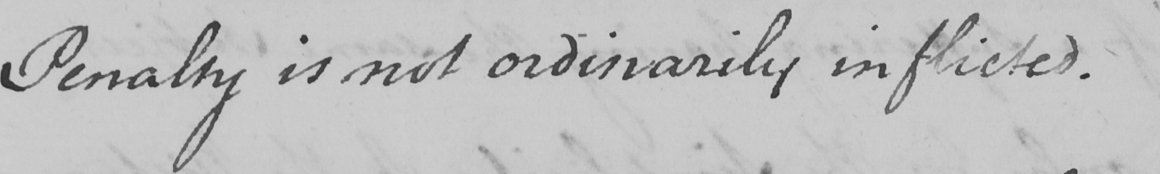What text is written in this handwritten line? Penalty is not ordinarily inflicted . 